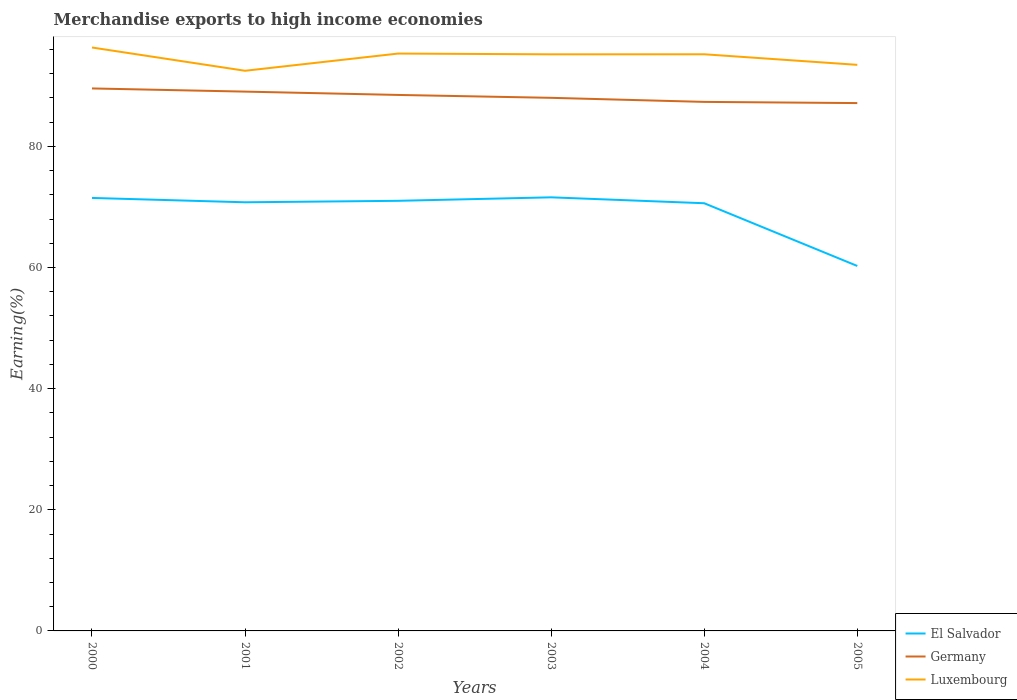Does the line corresponding to El Salvador intersect with the line corresponding to Luxembourg?
Your answer should be compact. No. Is the number of lines equal to the number of legend labels?
Your response must be concise. Yes. Across all years, what is the maximum percentage of amount earned from merchandise exports in Germany?
Ensure brevity in your answer.  87.14. What is the total percentage of amount earned from merchandise exports in El Salvador in the graph?
Make the answer very short. 10.76. What is the difference between the highest and the second highest percentage of amount earned from merchandise exports in Germany?
Make the answer very short. 2.42. What is the difference between the highest and the lowest percentage of amount earned from merchandise exports in Germany?
Provide a succinct answer. 3. Is the percentage of amount earned from merchandise exports in Luxembourg strictly greater than the percentage of amount earned from merchandise exports in Germany over the years?
Provide a short and direct response. No. Are the values on the major ticks of Y-axis written in scientific E-notation?
Give a very brief answer. No. Does the graph contain any zero values?
Keep it short and to the point. No. Does the graph contain grids?
Make the answer very short. No. Where does the legend appear in the graph?
Ensure brevity in your answer.  Bottom right. How are the legend labels stacked?
Your answer should be compact. Vertical. What is the title of the graph?
Your answer should be very brief. Merchandise exports to high income economies. What is the label or title of the X-axis?
Ensure brevity in your answer.  Years. What is the label or title of the Y-axis?
Offer a very short reply. Earning(%). What is the Earning(%) of El Salvador in 2000?
Keep it short and to the point. 71.48. What is the Earning(%) of Germany in 2000?
Give a very brief answer. 89.56. What is the Earning(%) of Luxembourg in 2000?
Provide a succinct answer. 96.32. What is the Earning(%) of El Salvador in 2001?
Offer a terse response. 70.76. What is the Earning(%) of Germany in 2001?
Offer a terse response. 89.04. What is the Earning(%) of Luxembourg in 2001?
Provide a succinct answer. 92.48. What is the Earning(%) of El Salvador in 2002?
Ensure brevity in your answer.  71.01. What is the Earning(%) of Germany in 2002?
Offer a very short reply. 88.49. What is the Earning(%) in Luxembourg in 2002?
Provide a succinct answer. 95.32. What is the Earning(%) in El Salvador in 2003?
Make the answer very short. 71.58. What is the Earning(%) of Germany in 2003?
Provide a succinct answer. 88.01. What is the Earning(%) in Luxembourg in 2003?
Keep it short and to the point. 95.19. What is the Earning(%) in El Salvador in 2004?
Offer a very short reply. 70.61. What is the Earning(%) of Germany in 2004?
Offer a very short reply. 87.34. What is the Earning(%) of Luxembourg in 2004?
Ensure brevity in your answer.  95.2. What is the Earning(%) in El Salvador in 2005?
Your response must be concise. 60.25. What is the Earning(%) in Germany in 2005?
Offer a terse response. 87.14. What is the Earning(%) of Luxembourg in 2005?
Provide a succinct answer. 93.45. Across all years, what is the maximum Earning(%) of El Salvador?
Provide a succinct answer. 71.58. Across all years, what is the maximum Earning(%) of Germany?
Offer a very short reply. 89.56. Across all years, what is the maximum Earning(%) in Luxembourg?
Offer a terse response. 96.32. Across all years, what is the minimum Earning(%) in El Salvador?
Provide a succinct answer. 60.25. Across all years, what is the minimum Earning(%) in Germany?
Offer a terse response. 87.14. Across all years, what is the minimum Earning(%) of Luxembourg?
Keep it short and to the point. 92.48. What is the total Earning(%) in El Salvador in the graph?
Your answer should be very brief. 415.69. What is the total Earning(%) in Germany in the graph?
Give a very brief answer. 529.57. What is the total Earning(%) in Luxembourg in the graph?
Your answer should be very brief. 567.96. What is the difference between the Earning(%) in El Salvador in 2000 and that in 2001?
Give a very brief answer. 0.72. What is the difference between the Earning(%) in Germany in 2000 and that in 2001?
Ensure brevity in your answer.  0.53. What is the difference between the Earning(%) in Luxembourg in 2000 and that in 2001?
Offer a terse response. 3.84. What is the difference between the Earning(%) of El Salvador in 2000 and that in 2002?
Your response must be concise. 0.47. What is the difference between the Earning(%) of Germany in 2000 and that in 2002?
Give a very brief answer. 1.08. What is the difference between the Earning(%) in Luxembourg in 2000 and that in 2002?
Give a very brief answer. 1. What is the difference between the Earning(%) of El Salvador in 2000 and that in 2003?
Give a very brief answer. -0.1. What is the difference between the Earning(%) in Germany in 2000 and that in 2003?
Your answer should be compact. 1.55. What is the difference between the Earning(%) of Luxembourg in 2000 and that in 2003?
Your answer should be compact. 1.13. What is the difference between the Earning(%) in El Salvador in 2000 and that in 2004?
Make the answer very short. 0.87. What is the difference between the Earning(%) of Germany in 2000 and that in 2004?
Your response must be concise. 2.22. What is the difference between the Earning(%) in Luxembourg in 2000 and that in 2004?
Ensure brevity in your answer.  1.12. What is the difference between the Earning(%) in El Salvador in 2000 and that in 2005?
Your answer should be very brief. 11.23. What is the difference between the Earning(%) in Germany in 2000 and that in 2005?
Your answer should be compact. 2.42. What is the difference between the Earning(%) of Luxembourg in 2000 and that in 2005?
Your answer should be very brief. 2.86. What is the difference between the Earning(%) in El Salvador in 2001 and that in 2002?
Offer a terse response. -0.24. What is the difference between the Earning(%) of Germany in 2001 and that in 2002?
Give a very brief answer. 0.55. What is the difference between the Earning(%) of Luxembourg in 2001 and that in 2002?
Your response must be concise. -2.84. What is the difference between the Earning(%) of El Salvador in 2001 and that in 2003?
Provide a short and direct response. -0.82. What is the difference between the Earning(%) of Germany in 2001 and that in 2003?
Your answer should be compact. 1.03. What is the difference between the Earning(%) in Luxembourg in 2001 and that in 2003?
Ensure brevity in your answer.  -2.72. What is the difference between the Earning(%) of El Salvador in 2001 and that in 2004?
Keep it short and to the point. 0.16. What is the difference between the Earning(%) of Germany in 2001 and that in 2004?
Keep it short and to the point. 1.7. What is the difference between the Earning(%) of Luxembourg in 2001 and that in 2004?
Ensure brevity in your answer.  -2.72. What is the difference between the Earning(%) of El Salvador in 2001 and that in 2005?
Your answer should be very brief. 10.51. What is the difference between the Earning(%) in Germany in 2001 and that in 2005?
Keep it short and to the point. 1.89. What is the difference between the Earning(%) in Luxembourg in 2001 and that in 2005?
Your answer should be very brief. -0.98. What is the difference between the Earning(%) of El Salvador in 2002 and that in 2003?
Your answer should be very brief. -0.58. What is the difference between the Earning(%) of Germany in 2002 and that in 2003?
Make the answer very short. 0.48. What is the difference between the Earning(%) in Luxembourg in 2002 and that in 2003?
Provide a succinct answer. 0.13. What is the difference between the Earning(%) of El Salvador in 2002 and that in 2004?
Provide a short and direct response. 0.4. What is the difference between the Earning(%) of Germany in 2002 and that in 2004?
Ensure brevity in your answer.  1.15. What is the difference between the Earning(%) in Luxembourg in 2002 and that in 2004?
Make the answer very short. 0.12. What is the difference between the Earning(%) in El Salvador in 2002 and that in 2005?
Provide a succinct answer. 10.76. What is the difference between the Earning(%) in Germany in 2002 and that in 2005?
Your answer should be very brief. 1.34. What is the difference between the Earning(%) of Luxembourg in 2002 and that in 2005?
Your answer should be compact. 1.86. What is the difference between the Earning(%) of El Salvador in 2003 and that in 2004?
Provide a short and direct response. 0.98. What is the difference between the Earning(%) of Germany in 2003 and that in 2004?
Keep it short and to the point. 0.67. What is the difference between the Earning(%) of Luxembourg in 2003 and that in 2004?
Offer a very short reply. -0.01. What is the difference between the Earning(%) in El Salvador in 2003 and that in 2005?
Your response must be concise. 11.33. What is the difference between the Earning(%) in Germany in 2003 and that in 2005?
Offer a terse response. 0.87. What is the difference between the Earning(%) in Luxembourg in 2003 and that in 2005?
Ensure brevity in your answer.  1.74. What is the difference between the Earning(%) of El Salvador in 2004 and that in 2005?
Provide a succinct answer. 10.36. What is the difference between the Earning(%) of Germany in 2004 and that in 2005?
Make the answer very short. 0.2. What is the difference between the Earning(%) of Luxembourg in 2004 and that in 2005?
Your response must be concise. 1.74. What is the difference between the Earning(%) in El Salvador in 2000 and the Earning(%) in Germany in 2001?
Provide a short and direct response. -17.55. What is the difference between the Earning(%) in El Salvador in 2000 and the Earning(%) in Luxembourg in 2001?
Ensure brevity in your answer.  -21. What is the difference between the Earning(%) of Germany in 2000 and the Earning(%) of Luxembourg in 2001?
Provide a succinct answer. -2.92. What is the difference between the Earning(%) of El Salvador in 2000 and the Earning(%) of Germany in 2002?
Keep it short and to the point. -17. What is the difference between the Earning(%) in El Salvador in 2000 and the Earning(%) in Luxembourg in 2002?
Your answer should be compact. -23.84. What is the difference between the Earning(%) of Germany in 2000 and the Earning(%) of Luxembourg in 2002?
Give a very brief answer. -5.76. What is the difference between the Earning(%) in El Salvador in 2000 and the Earning(%) in Germany in 2003?
Provide a succinct answer. -16.53. What is the difference between the Earning(%) of El Salvador in 2000 and the Earning(%) of Luxembourg in 2003?
Your answer should be compact. -23.71. What is the difference between the Earning(%) of Germany in 2000 and the Earning(%) of Luxembourg in 2003?
Keep it short and to the point. -5.63. What is the difference between the Earning(%) of El Salvador in 2000 and the Earning(%) of Germany in 2004?
Your answer should be compact. -15.86. What is the difference between the Earning(%) of El Salvador in 2000 and the Earning(%) of Luxembourg in 2004?
Give a very brief answer. -23.72. What is the difference between the Earning(%) in Germany in 2000 and the Earning(%) in Luxembourg in 2004?
Keep it short and to the point. -5.64. What is the difference between the Earning(%) of El Salvador in 2000 and the Earning(%) of Germany in 2005?
Keep it short and to the point. -15.66. What is the difference between the Earning(%) of El Salvador in 2000 and the Earning(%) of Luxembourg in 2005?
Provide a succinct answer. -21.97. What is the difference between the Earning(%) of Germany in 2000 and the Earning(%) of Luxembourg in 2005?
Ensure brevity in your answer.  -3.89. What is the difference between the Earning(%) of El Salvador in 2001 and the Earning(%) of Germany in 2002?
Offer a terse response. -17.72. What is the difference between the Earning(%) of El Salvador in 2001 and the Earning(%) of Luxembourg in 2002?
Ensure brevity in your answer.  -24.55. What is the difference between the Earning(%) in Germany in 2001 and the Earning(%) in Luxembourg in 2002?
Give a very brief answer. -6.28. What is the difference between the Earning(%) of El Salvador in 2001 and the Earning(%) of Germany in 2003?
Ensure brevity in your answer.  -17.24. What is the difference between the Earning(%) of El Salvador in 2001 and the Earning(%) of Luxembourg in 2003?
Your response must be concise. -24.43. What is the difference between the Earning(%) in Germany in 2001 and the Earning(%) in Luxembourg in 2003?
Your answer should be compact. -6.16. What is the difference between the Earning(%) in El Salvador in 2001 and the Earning(%) in Germany in 2004?
Your answer should be very brief. -16.57. What is the difference between the Earning(%) of El Salvador in 2001 and the Earning(%) of Luxembourg in 2004?
Make the answer very short. -24.43. What is the difference between the Earning(%) of Germany in 2001 and the Earning(%) of Luxembourg in 2004?
Keep it short and to the point. -6.16. What is the difference between the Earning(%) of El Salvador in 2001 and the Earning(%) of Germany in 2005?
Offer a very short reply. -16.38. What is the difference between the Earning(%) of El Salvador in 2001 and the Earning(%) of Luxembourg in 2005?
Offer a terse response. -22.69. What is the difference between the Earning(%) in Germany in 2001 and the Earning(%) in Luxembourg in 2005?
Give a very brief answer. -4.42. What is the difference between the Earning(%) of El Salvador in 2002 and the Earning(%) of Germany in 2003?
Provide a succinct answer. -17. What is the difference between the Earning(%) in El Salvador in 2002 and the Earning(%) in Luxembourg in 2003?
Your response must be concise. -24.18. What is the difference between the Earning(%) of Germany in 2002 and the Earning(%) of Luxembourg in 2003?
Provide a short and direct response. -6.71. What is the difference between the Earning(%) of El Salvador in 2002 and the Earning(%) of Germany in 2004?
Keep it short and to the point. -16.33. What is the difference between the Earning(%) of El Salvador in 2002 and the Earning(%) of Luxembourg in 2004?
Make the answer very short. -24.19. What is the difference between the Earning(%) of Germany in 2002 and the Earning(%) of Luxembourg in 2004?
Provide a short and direct response. -6.71. What is the difference between the Earning(%) in El Salvador in 2002 and the Earning(%) in Germany in 2005?
Ensure brevity in your answer.  -16.14. What is the difference between the Earning(%) of El Salvador in 2002 and the Earning(%) of Luxembourg in 2005?
Offer a terse response. -22.45. What is the difference between the Earning(%) of Germany in 2002 and the Earning(%) of Luxembourg in 2005?
Ensure brevity in your answer.  -4.97. What is the difference between the Earning(%) of El Salvador in 2003 and the Earning(%) of Germany in 2004?
Make the answer very short. -15.75. What is the difference between the Earning(%) of El Salvador in 2003 and the Earning(%) of Luxembourg in 2004?
Ensure brevity in your answer.  -23.62. What is the difference between the Earning(%) in Germany in 2003 and the Earning(%) in Luxembourg in 2004?
Provide a succinct answer. -7.19. What is the difference between the Earning(%) in El Salvador in 2003 and the Earning(%) in Germany in 2005?
Offer a very short reply. -15.56. What is the difference between the Earning(%) of El Salvador in 2003 and the Earning(%) of Luxembourg in 2005?
Your answer should be compact. -21.87. What is the difference between the Earning(%) of Germany in 2003 and the Earning(%) of Luxembourg in 2005?
Your response must be concise. -5.45. What is the difference between the Earning(%) in El Salvador in 2004 and the Earning(%) in Germany in 2005?
Make the answer very short. -16.54. What is the difference between the Earning(%) in El Salvador in 2004 and the Earning(%) in Luxembourg in 2005?
Give a very brief answer. -22.85. What is the difference between the Earning(%) in Germany in 2004 and the Earning(%) in Luxembourg in 2005?
Ensure brevity in your answer.  -6.12. What is the average Earning(%) of El Salvador per year?
Provide a succinct answer. 69.28. What is the average Earning(%) in Germany per year?
Keep it short and to the point. 88.26. What is the average Earning(%) of Luxembourg per year?
Offer a very short reply. 94.66. In the year 2000, what is the difference between the Earning(%) in El Salvador and Earning(%) in Germany?
Make the answer very short. -18.08. In the year 2000, what is the difference between the Earning(%) of El Salvador and Earning(%) of Luxembourg?
Your response must be concise. -24.84. In the year 2000, what is the difference between the Earning(%) in Germany and Earning(%) in Luxembourg?
Your response must be concise. -6.76. In the year 2001, what is the difference between the Earning(%) of El Salvador and Earning(%) of Germany?
Ensure brevity in your answer.  -18.27. In the year 2001, what is the difference between the Earning(%) in El Salvador and Earning(%) in Luxembourg?
Provide a short and direct response. -21.71. In the year 2001, what is the difference between the Earning(%) of Germany and Earning(%) of Luxembourg?
Your response must be concise. -3.44. In the year 2002, what is the difference between the Earning(%) in El Salvador and Earning(%) in Germany?
Make the answer very short. -17.48. In the year 2002, what is the difference between the Earning(%) of El Salvador and Earning(%) of Luxembourg?
Your answer should be compact. -24.31. In the year 2002, what is the difference between the Earning(%) in Germany and Earning(%) in Luxembourg?
Offer a terse response. -6.83. In the year 2003, what is the difference between the Earning(%) in El Salvador and Earning(%) in Germany?
Keep it short and to the point. -16.42. In the year 2003, what is the difference between the Earning(%) in El Salvador and Earning(%) in Luxembourg?
Offer a terse response. -23.61. In the year 2003, what is the difference between the Earning(%) of Germany and Earning(%) of Luxembourg?
Give a very brief answer. -7.18. In the year 2004, what is the difference between the Earning(%) in El Salvador and Earning(%) in Germany?
Make the answer very short. -16.73. In the year 2004, what is the difference between the Earning(%) of El Salvador and Earning(%) of Luxembourg?
Keep it short and to the point. -24.59. In the year 2004, what is the difference between the Earning(%) in Germany and Earning(%) in Luxembourg?
Keep it short and to the point. -7.86. In the year 2005, what is the difference between the Earning(%) in El Salvador and Earning(%) in Germany?
Provide a succinct answer. -26.89. In the year 2005, what is the difference between the Earning(%) of El Salvador and Earning(%) of Luxembourg?
Give a very brief answer. -33.2. In the year 2005, what is the difference between the Earning(%) in Germany and Earning(%) in Luxembourg?
Your answer should be compact. -6.31. What is the ratio of the Earning(%) in Germany in 2000 to that in 2001?
Provide a succinct answer. 1.01. What is the ratio of the Earning(%) of Luxembourg in 2000 to that in 2001?
Ensure brevity in your answer.  1.04. What is the ratio of the Earning(%) of El Salvador in 2000 to that in 2002?
Make the answer very short. 1.01. What is the ratio of the Earning(%) in Germany in 2000 to that in 2002?
Give a very brief answer. 1.01. What is the ratio of the Earning(%) of Luxembourg in 2000 to that in 2002?
Provide a succinct answer. 1.01. What is the ratio of the Earning(%) of Germany in 2000 to that in 2003?
Make the answer very short. 1.02. What is the ratio of the Earning(%) of Luxembourg in 2000 to that in 2003?
Provide a succinct answer. 1.01. What is the ratio of the Earning(%) in El Salvador in 2000 to that in 2004?
Offer a terse response. 1.01. What is the ratio of the Earning(%) of Germany in 2000 to that in 2004?
Your answer should be compact. 1.03. What is the ratio of the Earning(%) of Luxembourg in 2000 to that in 2004?
Your answer should be very brief. 1.01. What is the ratio of the Earning(%) of El Salvador in 2000 to that in 2005?
Your response must be concise. 1.19. What is the ratio of the Earning(%) of Germany in 2000 to that in 2005?
Offer a terse response. 1.03. What is the ratio of the Earning(%) in Luxembourg in 2000 to that in 2005?
Make the answer very short. 1.03. What is the ratio of the Earning(%) in El Salvador in 2001 to that in 2002?
Offer a terse response. 1. What is the ratio of the Earning(%) in Germany in 2001 to that in 2002?
Offer a terse response. 1.01. What is the ratio of the Earning(%) of Luxembourg in 2001 to that in 2002?
Keep it short and to the point. 0.97. What is the ratio of the Earning(%) in El Salvador in 2001 to that in 2003?
Provide a short and direct response. 0.99. What is the ratio of the Earning(%) in Germany in 2001 to that in 2003?
Provide a short and direct response. 1.01. What is the ratio of the Earning(%) in Luxembourg in 2001 to that in 2003?
Make the answer very short. 0.97. What is the ratio of the Earning(%) in Germany in 2001 to that in 2004?
Offer a very short reply. 1.02. What is the ratio of the Earning(%) of Luxembourg in 2001 to that in 2004?
Offer a very short reply. 0.97. What is the ratio of the Earning(%) in El Salvador in 2001 to that in 2005?
Provide a short and direct response. 1.17. What is the ratio of the Earning(%) in Germany in 2001 to that in 2005?
Your answer should be compact. 1.02. What is the ratio of the Earning(%) in El Salvador in 2002 to that in 2003?
Give a very brief answer. 0.99. What is the ratio of the Earning(%) of Germany in 2002 to that in 2003?
Make the answer very short. 1.01. What is the ratio of the Earning(%) of Luxembourg in 2002 to that in 2003?
Your answer should be compact. 1. What is the ratio of the Earning(%) of Germany in 2002 to that in 2004?
Give a very brief answer. 1.01. What is the ratio of the Earning(%) of El Salvador in 2002 to that in 2005?
Your answer should be compact. 1.18. What is the ratio of the Earning(%) in Germany in 2002 to that in 2005?
Give a very brief answer. 1.02. What is the ratio of the Earning(%) of Luxembourg in 2002 to that in 2005?
Offer a terse response. 1.02. What is the ratio of the Earning(%) in El Salvador in 2003 to that in 2004?
Your answer should be very brief. 1.01. What is the ratio of the Earning(%) in Germany in 2003 to that in 2004?
Provide a short and direct response. 1.01. What is the ratio of the Earning(%) of El Salvador in 2003 to that in 2005?
Offer a very short reply. 1.19. What is the ratio of the Earning(%) of Germany in 2003 to that in 2005?
Give a very brief answer. 1.01. What is the ratio of the Earning(%) of Luxembourg in 2003 to that in 2005?
Offer a terse response. 1.02. What is the ratio of the Earning(%) in El Salvador in 2004 to that in 2005?
Ensure brevity in your answer.  1.17. What is the ratio of the Earning(%) in Luxembourg in 2004 to that in 2005?
Give a very brief answer. 1.02. What is the difference between the highest and the second highest Earning(%) of El Salvador?
Make the answer very short. 0.1. What is the difference between the highest and the second highest Earning(%) of Germany?
Keep it short and to the point. 0.53. What is the difference between the highest and the second highest Earning(%) in Luxembourg?
Your response must be concise. 1. What is the difference between the highest and the lowest Earning(%) in El Salvador?
Give a very brief answer. 11.33. What is the difference between the highest and the lowest Earning(%) in Germany?
Provide a succinct answer. 2.42. What is the difference between the highest and the lowest Earning(%) in Luxembourg?
Give a very brief answer. 3.84. 